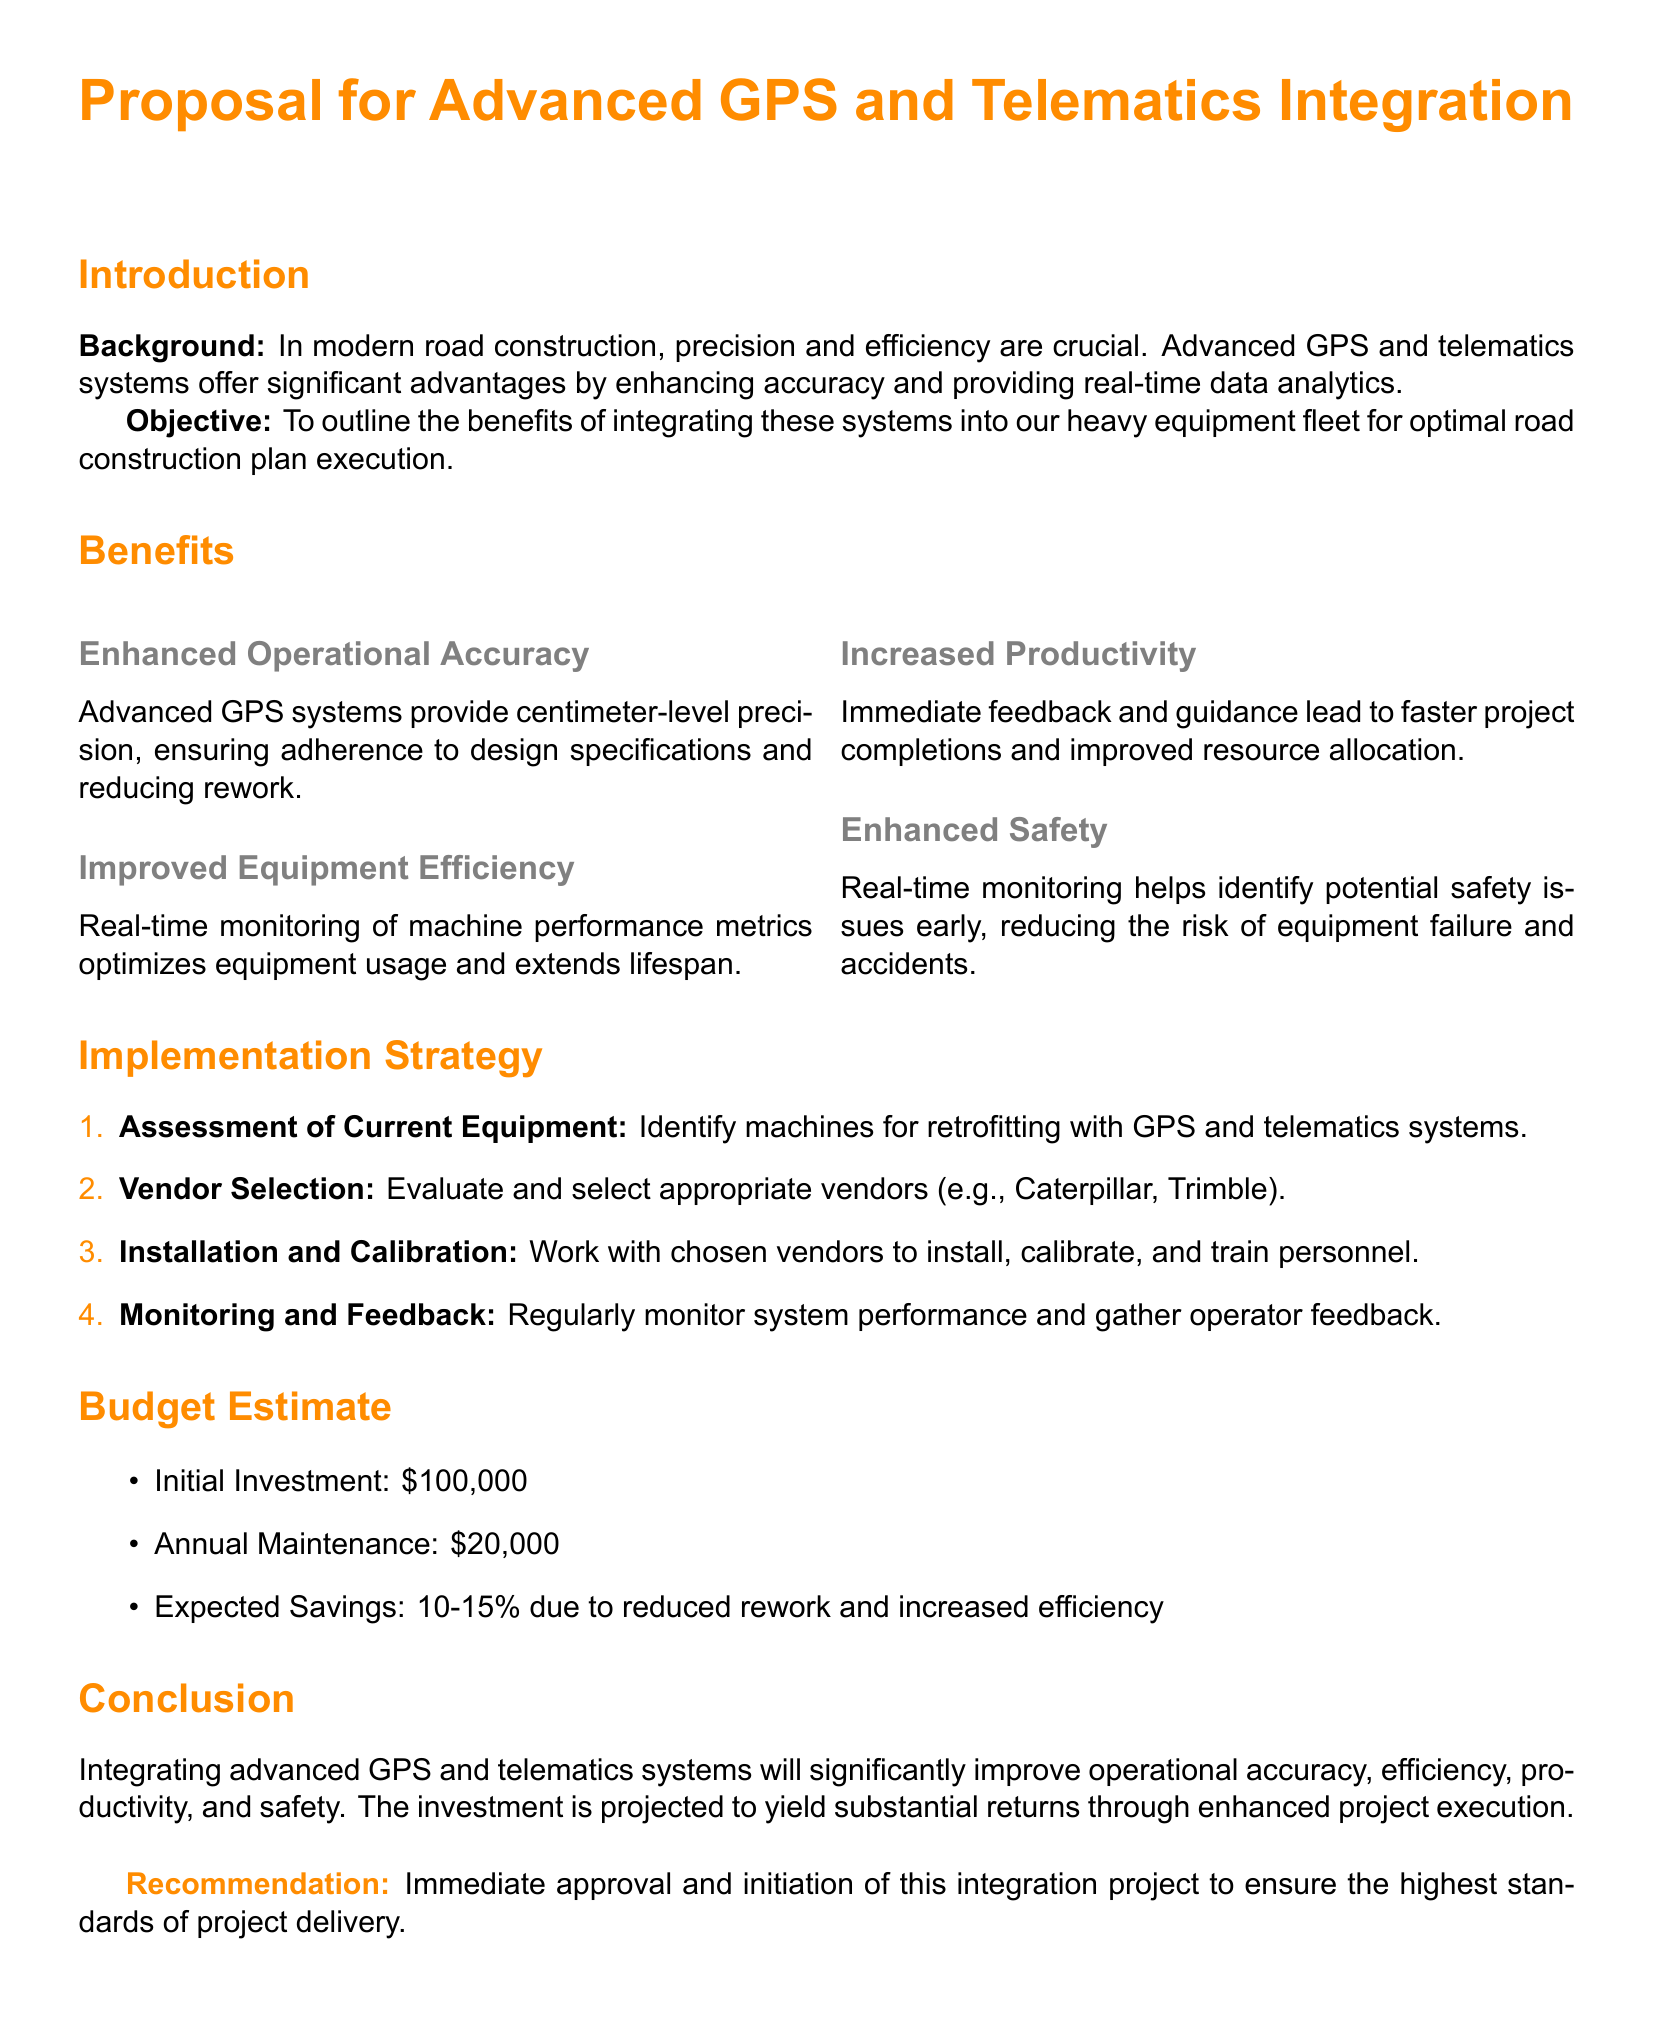What is the initial investment for the project? The initial investment is listed in the budget estimate section of the document.
Answer: $100,000 What are the expected savings from the integration? Expected savings are mentioned in the budget estimate section as a percentage of reduced rework and increased efficiency.
Answer: 10-15% Who are the suggested vendors for the equipment? The vendors for selection are identified in the implementation strategy section of the document.
Answer: Caterpillar, Trimble What is one of the benefits of using advanced GPS systems? Benefits are discussed in the benefits section, specifically their impact on operational accuracy.
Answer: Enhanced Operational Accuracy What is the purpose of the proposal? The objective of the proposal outlines its main focus regarding the use of advanced systems in heavy equipment.
Answer: To outline the benefits of integrating these systems into our heavy equipment fleet for optimal road construction plan execution What is one reason for improved equipment efficiency? The reasons are discussed in the benefits section concerning machine performance metrics.
Answer: Real-time monitoring of machine performance metrics 